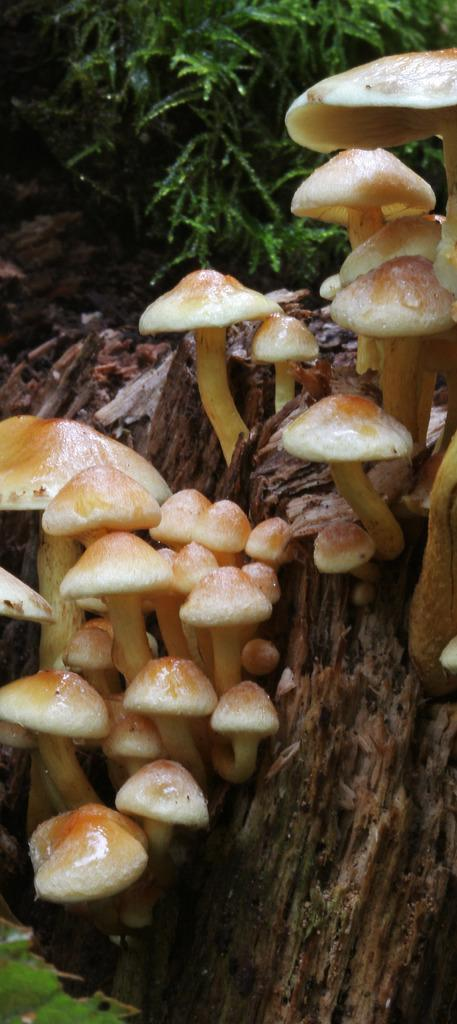What is present on the tree branch in the image? Mushrooms are growing on the tree branch in the image. What else can be seen in the image besides the tree branch and mushrooms? There are plants visible behind the tree branch. How does the jelly interact with the mushrooms on the tree branch? There is no jelly present in the image, so it cannot interact with the mushrooms. 